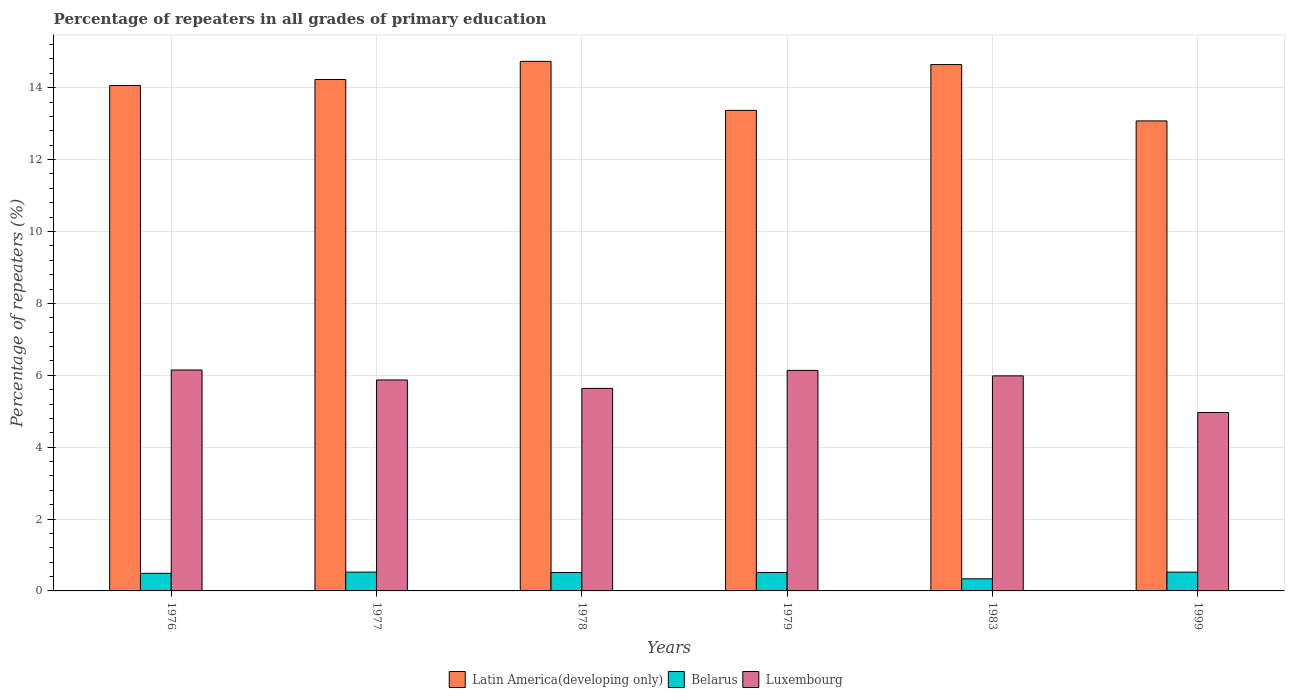How many groups of bars are there?
Offer a very short reply. 6. Are the number of bars on each tick of the X-axis equal?
Make the answer very short. Yes. How many bars are there on the 3rd tick from the left?
Keep it short and to the point. 3. How many bars are there on the 6th tick from the right?
Your answer should be very brief. 3. What is the label of the 6th group of bars from the left?
Your answer should be very brief. 1999. What is the percentage of repeaters in Latin America(developing only) in 1977?
Your answer should be very brief. 14.23. Across all years, what is the maximum percentage of repeaters in Latin America(developing only)?
Keep it short and to the point. 14.73. Across all years, what is the minimum percentage of repeaters in Luxembourg?
Provide a succinct answer. 4.96. In which year was the percentage of repeaters in Latin America(developing only) maximum?
Keep it short and to the point. 1978. What is the total percentage of repeaters in Latin America(developing only) in the graph?
Ensure brevity in your answer.  84.11. What is the difference between the percentage of repeaters in Luxembourg in 1978 and that in 1983?
Offer a very short reply. -0.35. What is the difference between the percentage of repeaters in Luxembourg in 1976 and the percentage of repeaters in Latin America(developing only) in 1983?
Offer a terse response. -8.5. What is the average percentage of repeaters in Luxembourg per year?
Make the answer very short. 5.79. In the year 1978, what is the difference between the percentage of repeaters in Latin America(developing only) and percentage of repeaters in Luxembourg?
Your answer should be very brief. 9.1. In how many years, is the percentage of repeaters in Belarus greater than 4.4 %?
Your answer should be very brief. 0. What is the ratio of the percentage of repeaters in Luxembourg in 1979 to that in 1999?
Your response must be concise. 1.24. Is the percentage of repeaters in Luxembourg in 1978 less than that in 1979?
Make the answer very short. Yes. Is the difference between the percentage of repeaters in Latin America(developing only) in 1976 and 1977 greater than the difference between the percentage of repeaters in Luxembourg in 1976 and 1977?
Your response must be concise. No. What is the difference between the highest and the second highest percentage of repeaters in Latin America(developing only)?
Give a very brief answer. 0.09. What is the difference between the highest and the lowest percentage of repeaters in Latin America(developing only)?
Offer a very short reply. 1.66. Is the sum of the percentage of repeaters in Latin America(developing only) in 1983 and 1999 greater than the maximum percentage of repeaters in Luxembourg across all years?
Make the answer very short. Yes. What does the 2nd bar from the left in 1977 represents?
Your answer should be compact. Belarus. What does the 2nd bar from the right in 1999 represents?
Your answer should be compact. Belarus. What is the difference between two consecutive major ticks on the Y-axis?
Your answer should be very brief. 2. Are the values on the major ticks of Y-axis written in scientific E-notation?
Make the answer very short. No. Does the graph contain grids?
Give a very brief answer. Yes. How many legend labels are there?
Your answer should be compact. 3. What is the title of the graph?
Make the answer very short. Percentage of repeaters in all grades of primary education. Does "Saudi Arabia" appear as one of the legend labels in the graph?
Offer a terse response. No. What is the label or title of the X-axis?
Make the answer very short. Years. What is the label or title of the Y-axis?
Your answer should be very brief. Percentage of repeaters (%). What is the Percentage of repeaters (%) of Latin America(developing only) in 1976?
Your answer should be very brief. 14.06. What is the Percentage of repeaters (%) of Belarus in 1976?
Offer a very short reply. 0.49. What is the Percentage of repeaters (%) in Luxembourg in 1976?
Provide a short and direct response. 6.15. What is the Percentage of repeaters (%) in Latin America(developing only) in 1977?
Your answer should be compact. 14.23. What is the Percentage of repeaters (%) in Belarus in 1977?
Your response must be concise. 0.52. What is the Percentage of repeaters (%) of Luxembourg in 1977?
Keep it short and to the point. 5.87. What is the Percentage of repeaters (%) of Latin America(developing only) in 1978?
Ensure brevity in your answer.  14.73. What is the Percentage of repeaters (%) of Belarus in 1978?
Your answer should be compact. 0.51. What is the Percentage of repeaters (%) in Luxembourg in 1978?
Provide a short and direct response. 5.63. What is the Percentage of repeaters (%) in Latin America(developing only) in 1979?
Your response must be concise. 13.37. What is the Percentage of repeaters (%) of Belarus in 1979?
Ensure brevity in your answer.  0.51. What is the Percentage of repeaters (%) in Luxembourg in 1979?
Your answer should be very brief. 6.14. What is the Percentage of repeaters (%) of Latin America(developing only) in 1983?
Ensure brevity in your answer.  14.64. What is the Percentage of repeaters (%) in Belarus in 1983?
Your answer should be very brief. 0.34. What is the Percentage of repeaters (%) in Luxembourg in 1983?
Ensure brevity in your answer.  5.98. What is the Percentage of repeaters (%) of Latin America(developing only) in 1999?
Your answer should be very brief. 13.08. What is the Percentage of repeaters (%) of Belarus in 1999?
Make the answer very short. 0.52. What is the Percentage of repeaters (%) of Luxembourg in 1999?
Make the answer very short. 4.96. Across all years, what is the maximum Percentage of repeaters (%) in Latin America(developing only)?
Your answer should be compact. 14.73. Across all years, what is the maximum Percentage of repeaters (%) in Belarus?
Offer a very short reply. 0.52. Across all years, what is the maximum Percentage of repeaters (%) in Luxembourg?
Your response must be concise. 6.15. Across all years, what is the minimum Percentage of repeaters (%) in Latin America(developing only)?
Ensure brevity in your answer.  13.08. Across all years, what is the minimum Percentage of repeaters (%) in Belarus?
Provide a succinct answer. 0.34. Across all years, what is the minimum Percentage of repeaters (%) in Luxembourg?
Ensure brevity in your answer.  4.96. What is the total Percentage of repeaters (%) of Latin America(developing only) in the graph?
Provide a succinct answer. 84.11. What is the total Percentage of repeaters (%) in Belarus in the graph?
Provide a succinct answer. 2.9. What is the total Percentage of repeaters (%) in Luxembourg in the graph?
Your answer should be compact. 34.73. What is the difference between the Percentage of repeaters (%) of Latin America(developing only) in 1976 and that in 1977?
Give a very brief answer. -0.17. What is the difference between the Percentage of repeaters (%) in Belarus in 1976 and that in 1977?
Make the answer very short. -0.03. What is the difference between the Percentage of repeaters (%) of Luxembourg in 1976 and that in 1977?
Ensure brevity in your answer.  0.28. What is the difference between the Percentage of repeaters (%) of Latin America(developing only) in 1976 and that in 1978?
Your answer should be very brief. -0.67. What is the difference between the Percentage of repeaters (%) in Belarus in 1976 and that in 1978?
Your answer should be very brief. -0.02. What is the difference between the Percentage of repeaters (%) of Luxembourg in 1976 and that in 1978?
Offer a terse response. 0.51. What is the difference between the Percentage of repeaters (%) in Latin America(developing only) in 1976 and that in 1979?
Provide a short and direct response. 0.69. What is the difference between the Percentage of repeaters (%) of Belarus in 1976 and that in 1979?
Your answer should be very brief. -0.02. What is the difference between the Percentage of repeaters (%) of Luxembourg in 1976 and that in 1979?
Offer a very short reply. 0.01. What is the difference between the Percentage of repeaters (%) in Latin America(developing only) in 1976 and that in 1983?
Provide a short and direct response. -0.58. What is the difference between the Percentage of repeaters (%) of Belarus in 1976 and that in 1983?
Provide a succinct answer. 0.15. What is the difference between the Percentage of repeaters (%) in Luxembourg in 1976 and that in 1983?
Provide a succinct answer. 0.16. What is the difference between the Percentage of repeaters (%) of Latin America(developing only) in 1976 and that in 1999?
Provide a short and direct response. 0.99. What is the difference between the Percentage of repeaters (%) of Belarus in 1976 and that in 1999?
Give a very brief answer. -0.03. What is the difference between the Percentage of repeaters (%) in Luxembourg in 1976 and that in 1999?
Offer a terse response. 1.18. What is the difference between the Percentage of repeaters (%) in Latin America(developing only) in 1977 and that in 1978?
Give a very brief answer. -0.51. What is the difference between the Percentage of repeaters (%) of Belarus in 1977 and that in 1978?
Provide a short and direct response. 0.01. What is the difference between the Percentage of repeaters (%) in Luxembourg in 1977 and that in 1978?
Give a very brief answer. 0.23. What is the difference between the Percentage of repeaters (%) in Latin America(developing only) in 1977 and that in 1979?
Ensure brevity in your answer.  0.86. What is the difference between the Percentage of repeaters (%) of Luxembourg in 1977 and that in 1979?
Provide a short and direct response. -0.27. What is the difference between the Percentage of repeaters (%) in Latin America(developing only) in 1977 and that in 1983?
Provide a short and direct response. -0.42. What is the difference between the Percentage of repeaters (%) in Belarus in 1977 and that in 1983?
Your answer should be very brief. 0.19. What is the difference between the Percentage of repeaters (%) in Luxembourg in 1977 and that in 1983?
Offer a terse response. -0.11. What is the difference between the Percentage of repeaters (%) of Latin America(developing only) in 1977 and that in 1999?
Offer a very short reply. 1.15. What is the difference between the Percentage of repeaters (%) in Belarus in 1977 and that in 1999?
Your response must be concise. -0. What is the difference between the Percentage of repeaters (%) of Luxembourg in 1977 and that in 1999?
Your response must be concise. 0.91. What is the difference between the Percentage of repeaters (%) of Latin America(developing only) in 1978 and that in 1979?
Your answer should be very brief. 1.36. What is the difference between the Percentage of repeaters (%) in Belarus in 1978 and that in 1979?
Give a very brief answer. 0. What is the difference between the Percentage of repeaters (%) of Luxembourg in 1978 and that in 1979?
Keep it short and to the point. -0.5. What is the difference between the Percentage of repeaters (%) in Latin America(developing only) in 1978 and that in 1983?
Your answer should be very brief. 0.09. What is the difference between the Percentage of repeaters (%) of Belarus in 1978 and that in 1983?
Offer a terse response. 0.18. What is the difference between the Percentage of repeaters (%) of Luxembourg in 1978 and that in 1983?
Provide a succinct answer. -0.35. What is the difference between the Percentage of repeaters (%) in Latin America(developing only) in 1978 and that in 1999?
Make the answer very short. 1.66. What is the difference between the Percentage of repeaters (%) in Belarus in 1978 and that in 1999?
Offer a terse response. -0.01. What is the difference between the Percentage of repeaters (%) in Luxembourg in 1978 and that in 1999?
Ensure brevity in your answer.  0.67. What is the difference between the Percentage of repeaters (%) of Latin America(developing only) in 1979 and that in 1983?
Provide a succinct answer. -1.27. What is the difference between the Percentage of repeaters (%) in Belarus in 1979 and that in 1983?
Your response must be concise. 0.18. What is the difference between the Percentage of repeaters (%) in Luxembourg in 1979 and that in 1983?
Make the answer very short. 0.15. What is the difference between the Percentage of repeaters (%) of Latin America(developing only) in 1979 and that in 1999?
Provide a short and direct response. 0.29. What is the difference between the Percentage of repeaters (%) in Belarus in 1979 and that in 1999?
Give a very brief answer. -0.01. What is the difference between the Percentage of repeaters (%) in Luxembourg in 1979 and that in 1999?
Provide a short and direct response. 1.17. What is the difference between the Percentage of repeaters (%) of Latin America(developing only) in 1983 and that in 1999?
Offer a terse response. 1.57. What is the difference between the Percentage of repeaters (%) of Belarus in 1983 and that in 1999?
Your response must be concise. -0.19. What is the difference between the Percentage of repeaters (%) of Luxembourg in 1983 and that in 1999?
Your answer should be very brief. 1.02. What is the difference between the Percentage of repeaters (%) of Latin America(developing only) in 1976 and the Percentage of repeaters (%) of Belarus in 1977?
Your answer should be very brief. 13.54. What is the difference between the Percentage of repeaters (%) of Latin America(developing only) in 1976 and the Percentage of repeaters (%) of Luxembourg in 1977?
Provide a succinct answer. 8.19. What is the difference between the Percentage of repeaters (%) of Belarus in 1976 and the Percentage of repeaters (%) of Luxembourg in 1977?
Your response must be concise. -5.38. What is the difference between the Percentage of repeaters (%) in Latin America(developing only) in 1976 and the Percentage of repeaters (%) in Belarus in 1978?
Provide a short and direct response. 13.55. What is the difference between the Percentage of repeaters (%) in Latin America(developing only) in 1976 and the Percentage of repeaters (%) in Luxembourg in 1978?
Offer a very short reply. 8.43. What is the difference between the Percentage of repeaters (%) in Belarus in 1976 and the Percentage of repeaters (%) in Luxembourg in 1978?
Ensure brevity in your answer.  -5.15. What is the difference between the Percentage of repeaters (%) in Latin America(developing only) in 1976 and the Percentage of repeaters (%) in Belarus in 1979?
Offer a terse response. 13.55. What is the difference between the Percentage of repeaters (%) of Latin America(developing only) in 1976 and the Percentage of repeaters (%) of Luxembourg in 1979?
Ensure brevity in your answer.  7.93. What is the difference between the Percentage of repeaters (%) in Belarus in 1976 and the Percentage of repeaters (%) in Luxembourg in 1979?
Give a very brief answer. -5.65. What is the difference between the Percentage of repeaters (%) of Latin America(developing only) in 1976 and the Percentage of repeaters (%) of Belarus in 1983?
Make the answer very short. 13.73. What is the difference between the Percentage of repeaters (%) of Latin America(developing only) in 1976 and the Percentage of repeaters (%) of Luxembourg in 1983?
Give a very brief answer. 8.08. What is the difference between the Percentage of repeaters (%) in Belarus in 1976 and the Percentage of repeaters (%) in Luxembourg in 1983?
Provide a short and direct response. -5.49. What is the difference between the Percentage of repeaters (%) of Latin America(developing only) in 1976 and the Percentage of repeaters (%) of Belarus in 1999?
Offer a terse response. 13.54. What is the difference between the Percentage of repeaters (%) of Latin America(developing only) in 1976 and the Percentage of repeaters (%) of Luxembourg in 1999?
Offer a very short reply. 9.1. What is the difference between the Percentage of repeaters (%) in Belarus in 1976 and the Percentage of repeaters (%) in Luxembourg in 1999?
Offer a very short reply. -4.47. What is the difference between the Percentage of repeaters (%) in Latin America(developing only) in 1977 and the Percentage of repeaters (%) in Belarus in 1978?
Ensure brevity in your answer.  13.72. What is the difference between the Percentage of repeaters (%) of Latin America(developing only) in 1977 and the Percentage of repeaters (%) of Luxembourg in 1978?
Give a very brief answer. 8.59. What is the difference between the Percentage of repeaters (%) of Belarus in 1977 and the Percentage of repeaters (%) of Luxembourg in 1978?
Your response must be concise. -5.11. What is the difference between the Percentage of repeaters (%) of Latin America(developing only) in 1977 and the Percentage of repeaters (%) of Belarus in 1979?
Your response must be concise. 13.72. What is the difference between the Percentage of repeaters (%) in Latin America(developing only) in 1977 and the Percentage of repeaters (%) in Luxembourg in 1979?
Offer a very short reply. 8.09. What is the difference between the Percentage of repeaters (%) of Belarus in 1977 and the Percentage of repeaters (%) of Luxembourg in 1979?
Keep it short and to the point. -5.61. What is the difference between the Percentage of repeaters (%) in Latin America(developing only) in 1977 and the Percentage of repeaters (%) in Belarus in 1983?
Your answer should be very brief. 13.89. What is the difference between the Percentage of repeaters (%) in Latin America(developing only) in 1977 and the Percentage of repeaters (%) in Luxembourg in 1983?
Give a very brief answer. 8.24. What is the difference between the Percentage of repeaters (%) in Belarus in 1977 and the Percentage of repeaters (%) in Luxembourg in 1983?
Ensure brevity in your answer.  -5.46. What is the difference between the Percentage of repeaters (%) of Latin America(developing only) in 1977 and the Percentage of repeaters (%) of Belarus in 1999?
Keep it short and to the point. 13.71. What is the difference between the Percentage of repeaters (%) of Latin America(developing only) in 1977 and the Percentage of repeaters (%) of Luxembourg in 1999?
Offer a very short reply. 9.27. What is the difference between the Percentage of repeaters (%) of Belarus in 1977 and the Percentage of repeaters (%) of Luxembourg in 1999?
Provide a short and direct response. -4.44. What is the difference between the Percentage of repeaters (%) of Latin America(developing only) in 1978 and the Percentage of repeaters (%) of Belarus in 1979?
Give a very brief answer. 14.22. What is the difference between the Percentage of repeaters (%) of Latin America(developing only) in 1978 and the Percentage of repeaters (%) of Luxembourg in 1979?
Offer a very short reply. 8.6. What is the difference between the Percentage of repeaters (%) in Belarus in 1978 and the Percentage of repeaters (%) in Luxembourg in 1979?
Your answer should be very brief. -5.62. What is the difference between the Percentage of repeaters (%) in Latin America(developing only) in 1978 and the Percentage of repeaters (%) in Belarus in 1983?
Provide a succinct answer. 14.4. What is the difference between the Percentage of repeaters (%) of Latin America(developing only) in 1978 and the Percentage of repeaters (%) of Luxembourg in 1983?
Your response must be concise. 8.75. What is the difference between the Percentage of repeaters (%) in Belarus in 1978 and the Percentage of repeaters (%) in Luxembourg in 1983?
Offer a very short reply. -5.47. What is the difference between the Percentage of repeaters (%) in Latin America(developing only) in 1978 and the Percentage of repeaters (%) in Belarus in 1999?
Give a very brief answer. 14.21. What is the difference between the Percentage of repeaters (%) in Latin America(developing only) in 1978 and the Percentage of repeaters (%) in Luxembourg in 1999?
Give a very brief answer. 9.77. What is the difference between the Percentage of repeaters (%) of Belarus in 1978 and the Percentage of repeaters (%) of Luxembourg in 1999?
Your answer should be very brief. -4.45. What is the difference between the Percentage of repeaters (%) of Latin America(developing only) in 1979 and the Percentage of repeaters (%) of Belarus in 1983?
Offer a very short reply. 13.03. What is the difference between the Percentage of repeaters (%) in Latin America(developing only) in 1979 and the Percentage of repeaters (%) in Luxembourg in 1983?
Keep it short and to the point. 7.39. What is the difference between the Percentage of repeaters (%) of Belarus in 1979 and the Percentage of repeaters (%) of Luxembourg in 1983?
Ensure brevity in your answer.  -5.47. What is the difference between the Percentage of repeaters (%) in Latin America(developing only) in 1979 and the Percentage of repeaters (%) in Belarus in 1999?
Offer a terse response. 12.85. What is the difference between the Percentage of repeaters (%) of Latin America(developing only) in 1979 and the Percentage of repeaters (%) of Luxembourg in 1999?
Offer a terse response. 8.41. What is the difference between the Percentage of repeaters (%) in Belarus in 1979 and the Percentage of repeaters (%) in Luxembourg in 1999?
Your answer should be very brief. -4.45. What is the difference between the Percentage of repeaters (%) in Latin America(developing only) in 1983 and the Percentage of repeaters (%) in Belarus in 1999?
Make the answer very short. 14.12. What is the difference between the Percentage of repeaters (%) of Latin America(developing only) in 1983 and the Percentage of repeaters (%) of Luxembourg in 1999?
Give a very brief answer. 9.68. What is the difference between the Percentage of repeaters (%) of Belarus in 1983 and the Percentage of repeaters (%) of Luxembourg in 1999?
Your answer should be compact. -4.63. What is the average Percentage of repeaters (%) of Latin America(developing only) per year?
Ensure brevity in your answer.  14.02. What is the average Percentage of repeaters (%) in Belarus per year?
Offer a terse response. 0.48. What is the average Percentage of repeaters (%) of Luxembourg per year?
Provide a succinct answer. 5.79. In the year 1976, what is the difference between the Percentage of repeaters (%) of Latin America(developing only) and Percentage of repeaters (%) of Belarus?
Your answer should be very brief. 13.57. In the year 1976, what is the difference between the Percentage of repeaters (%) of Latin America(developing only) and Percentage of repeaters (%) of Luxembourg?
Make the answer very short. 7.92. In the year 1976, what is the difference between the Percentage of repeaters (%) in Belarus and Percentage of repeaters (%) in Luxembourg?
Give a very brief answer. -5.66. In the year 1977, what is the difference between the Percentage of repeaters (%) in Latin America(developing only) and Percentage of repeaters (%) in Belarus?
Make the answer very short. 13.71. In the year 1977, what is the difference between the Percentage of repeaters (%) in Latin America(developing only) and Percentage of repeaters (%) in Luxembourg?
Offer a terse response. 8.36. In the year 1977, what is the difference between the Percentage of repeaters (%) in Belarus and Percentage of repeaters (%) in Luxembourg?
Give a very brief answer. -5.35. In the year 1978, what is the difference between the Percentage of repeaters (%) in Latin America(developing only) and Percentage of repeaters (%) in Belarus?
Your response must be concise. 14.22. In the year 1978, what is the difference between the Percentage of repeaters (%) of Latin America(developing only) and Percentage of repeaters (%) of Luxembourg?
Your answer should be very brief. 9.1. In the year 1978, what is the difference between the Percentage of repeaters (%) of Belarus and Percentage of repeaters (%) of Luxembourg?
Your answer should be compact. -5.12. In the year 1979, what is the difference between the Percentage of repeaters (%) of Latin America(developing only) and Percentage of repeaters (%) of Belarus?
Offer a very short reply. 12.86. In the year 1979, what is the difference between the Percentage of repeaters (%) in Latin America(developing only) and Percentage of repeaters (%) in Luxembourg?
Provide a short and direct response. 7.23. In the year 1979, what is the difference between the Percentage of repeaters (%) in Belarus and Percentage of repeaters (%) in Luxembourg?
Provide a succinct answer. -5.62. In the year 1983, what is the difference between the Percentage of repeaters (%) in Latin America(developing only) and Percentage of repeaters (%) in Belarus?
Your response must be concise. 14.31. In the year 1983, what is the difference between the Percentage of repeaters (%) of Latin America(developing only) and Percentage of repeaters (%) of Luxembourg?
Your response must be concise. 8.66. In the year 1983, what is the difference between the Percentage of repeaters (%) in Belarus and Percentage of repeaters (%) in Luxembourg?
Offer a very short reply. -5.65. In the year 1999, what is the difference between the Percentage of repeaters (%) of Latin America(developing only) and Percentage of repeaters (%) of Belarus?
Provide a short and direct response. 12.55. In the year 1999, what is the difference between the Percentage of repeaters (%) in Latin America(developing only) and Percentage of repeaters (%) in Luxembourg?
Offer a terse response. 8.11. In the year 1999, what is the difference between the Percentage of repeaters (%) of Belarus and Percentage of repeaters (%) of Luxembourg?
Your answer should be very brief. -4.44. What is the ratio of the Percentage of repeaters (%) of Latin America(developing only) in 1976 to that in 1977?
Keep it short and to the point. 0.99. What is the ratio of the Percentage of repeaters (%) in Belarus in 1976 to that in 1977?
Ensure brevity in your answer.  0.94. What is the ratio of the Percentage of repeaters (%) of Luxembourg in 1976 to that in 1977?
Give a very brief answer. 1.05. What is the ratio of the Percentage of repeaters (%) of Latin America(developing only) in 1976 to that in 1978?
Offer a terse response. 0.95. What is the ratio of the Percentage of repeaters (%) of Belarus in 1976 to that in 1978?
Offer a terse response. 0.96. What is the ratio of the Percentage of repeaters (%) in Luxembourg in 1976 to that in 1978?
Offer a terse response. 1.09. What is the ratio of the Percentage of repeaters (%) of Latin America(developing only) in 1976 to that in 1979?
Make the answer very short. 1.05. What is the ratio of the Percentage of repeaters (%) in Belarus in 1976 to that in 1979?
Your response must be concise. 0.96. What is the ratio of the Percentage of repeaters (%) in Luxembourg in 1976 to that in 1979?
Make the answer very short. 1. What is the ratio of the Percentage of repeaters (%) of Latin America(developing only) in 1976 to that in 1983?
Provide a succinct answer. 0.96. What is the ratio of the Percentage of repeaters (%) of Belarus in 1976 to that in 1983?
Provide a short and direct response. 1.46. What is the ratio of the Percentage of repeaters (%) in Luxembourg in 1976 to that in 1983?
Your response must be concise. 1.03. What is the ratio of the Percentage of repeaters (%) in Latin America(developing only) in 1976 to that in 1999?
Make the answer very short. 1.08. What is the ratio of the Percentage of repeaters (%) in Belarus in 1976 to that in 1999?
Ensure brevity in your answer.  0.94. What is the ratio of the Percentage of repeaters (%) of Luxembourg in 1976 to that in 1999?
Ensure brevity in your answer.  1.24. What is the ratio of the Percentage of repeaters (%) of Latin America(developing only) in 1977 to that in 1978?
Make the answer very short. 0.97. What is the ratio of the Percentage of repeaters (%) in Belarus in 1977 to that in 1978?
Your response must be concise. 1.02. What is the ratio of the Percentage of repeaters (%) of Luxembourg in 1977 to that in 1978?
Provide a succinct answer. 1.04. What is the ratio of the Percentage of repeaters (%) of Latin America(developing only) in 1977 to that in 1979?
Make the answer very short. 1.06. What is the ratio of the Percentage of repeaters (%) of Belarus in 1977 to that in 1979?
Provide a short and direct response. 1.02. What is the ratio of the Percentage of repeaters (%) in Luxembourg in 1977 to that in 1979?
Your response must be concise. 0.96. What is the ratio of the Percentage of repeaters (%) of Latin America(developing only) in 1977 to that in 1983?
Offer a very short reply. 0.97. What is the ratio of the Percentage of repeaters (%) in Belarus in 1977 to that in 1983?
Your answer should be very brief. 1.55. What is the ratio of the Percentage of repeaters (%) of Latin America(developing only) in 1977 to that in 1999?
Your response must be concise. 1.09. What is the ratio of the Percentage of repeaters (%) of Belarus in 1977 to that in 1999?
Give a very brief answer. 1. What is the ratio of the Percentage of repeaters (%) of Luxembourg in 1977 to that in 1999?
Offer a terse response. 1.18. What is the ratio of the Percentage of repeaters (%) in Latin America(developing only) in 1978 to that in 1979?
Provide a short and direct response. 1.1. What is the ratio of the Percentage of repeaters (%) of Belarus in 1978 to that in 1979?
Your response must be concise. 1. What is the ratio of the Percentage of repeaters (%) in Luxembourg in 1978 to that in 1979?
Your response must be concise. 0.92. What is the ratio of the Percentage of repeaters (%) in Belarus in 1978 to that in 1983?
Your answer should be compact. 1.52. What is the ratio of the Percentage of repeaters (%) in Luxembourg in 1978 to that in 1983?
Your response must be concise. 0.94. What is the ratio of the Percentage of repeaters (%) of Latin America(developing only) in 1978 to that in 1999?
Your answer should be compact. 1.13. What is the ratio of the Percentage of repeaters (%) of Belarus in 1978 to that in 1999?
Your answer should be very brief. 0.98. What is the ratio of the Percentage of repeaters (%) of Luxembourg in 1978 to that in 1999?
Provide a short and direct response. 1.14. What is the ratio of the Percentage of repeaters (%) of Belarus in 1979 to that in 1983?
Offer a terse response. 1.52. What is the ratio of the Percentage of repeaters (%) of Luxembourg in 1979 to that in 1983?
Keep it short and to the point. 1.03. What is the ratio of the Percentage of repeaters (%) of Latin America(developing only) in 1979 to that in 1999?
Your answer should be compact. 1.02. What is the ratio of the Percentage of repeaters (%) in Belarus in 1979 to that in 1999?
Make the answer very short. 0.98. What is the ratio of the Percentage of repeaters (%) of Luxembourg in 1979 to that in 1999?
Ensure brevity in your answer.  1.24. What is the ratio of the Percentage of repeaters (%) in Latin America(developing only) in 1983 to that in 1999?
Give a very brief answer. 1.12. What is the ratio of the Percentage of repeaters (%) of Belarus in 1983 to that in 1999?
Give a very brief answer. 0.64. What is the ratio of the Percentage of repeaters (%) in Luxembourg in 1983 to that in 1999?
Ensure brevity in your answer.  1.21. What is the difference between the highest and the second highest Percentage of repeaters (%) in Latin America(developing only)?
Offer a very short reply. 0.09. What is the difference between the highest and the second highest Percentage of repeaters (%) in Luxembourg?
Provide a succinct answer. 0.01. What is the difference between the highest and the lowest Percentage of repeaters (%) of Latin America(developing only)?
Provide a succinct answer. 1.66. What is the difference between the highest and the lowest Percentage of repeaters (%) of Belarus?
Make the answer very short. 0.19. What is the difference between the highest and the lowest Percentage of repeaters (%) in Luxembourg?
Your answer should be very brief. 1.18. 